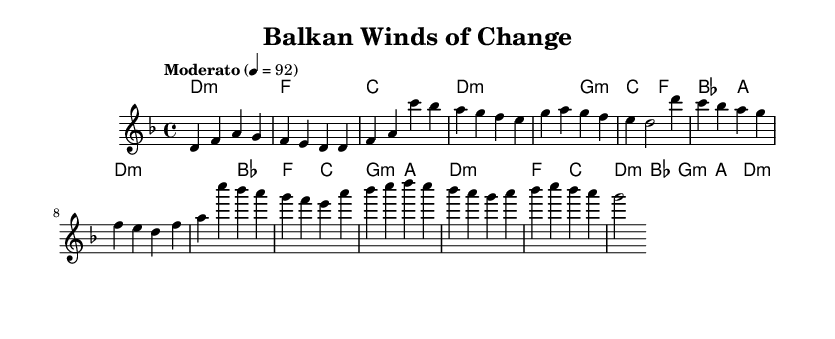What is the key signature of this music? The key signature is D minor, which consists of one flat (B♭). This is evident from the time signature indicated at the beginning of the score and the accompanying notes throughout the piece.
Answer: D minor What is the time signature of this music? The time signature is 4/4, as indicated at the beginning of the score right after the key signature. This means there are four beats per measure, making it a common time signature for many genres, including country folk.
Answer: 4/4 What is the tempo marking of this piece? The tempo marking is "Moderato" at a quarter note equals 92 beats per minute. This is shown at the beginning of the score and reflects a moderate pace, which is suitable for acoustic country folk songs.
Answer: Moderato, 92 How many measures are in the intro section? The intro section contains four measures. This can be counted by simply examining the first section of the melody line, where there are precisely four groups of note values, each separated by bar lines.
Answer: 4 What chords are used in the chorus section? The chords in the chorus section are D minor, B flat, F, C, G minor, and A. This is seen in the chord names written above the notes in the score, indicated at the beginning of the chorus part.
Answer: D minor, B flat, F, C, G minor, A Which part of the music is designated as the bridge? The bridge is identified as the specific section after the chorus and involves unique chord progressions and melodic patterns. The sheet music labels it as the bridge with distinct melodies and chords listed under that section.
Answer: Bridge What type of song structure is featured in this piece? The song structure features a common verse-chorus format often used in country folk songs. This can be inferred from the arrangement of the music where verses are followed by a chorus, and there is also a bridge, which complements this structure.
Answer: Verse-chorus 